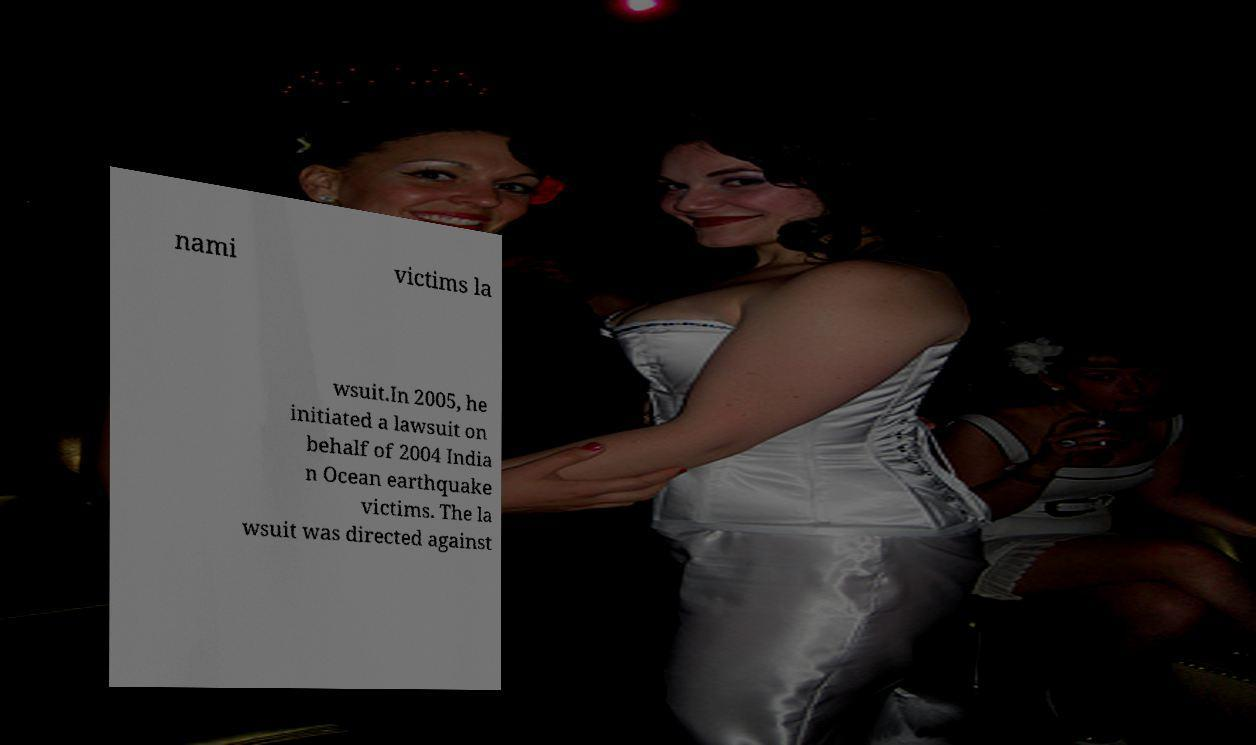Could you extract and type out the text from this image? nami victims la wsuit.In 2005, he initiated a lawsuit on behalf of 2004 India n Ocean earthquake victims. The la wsuit was directed against 